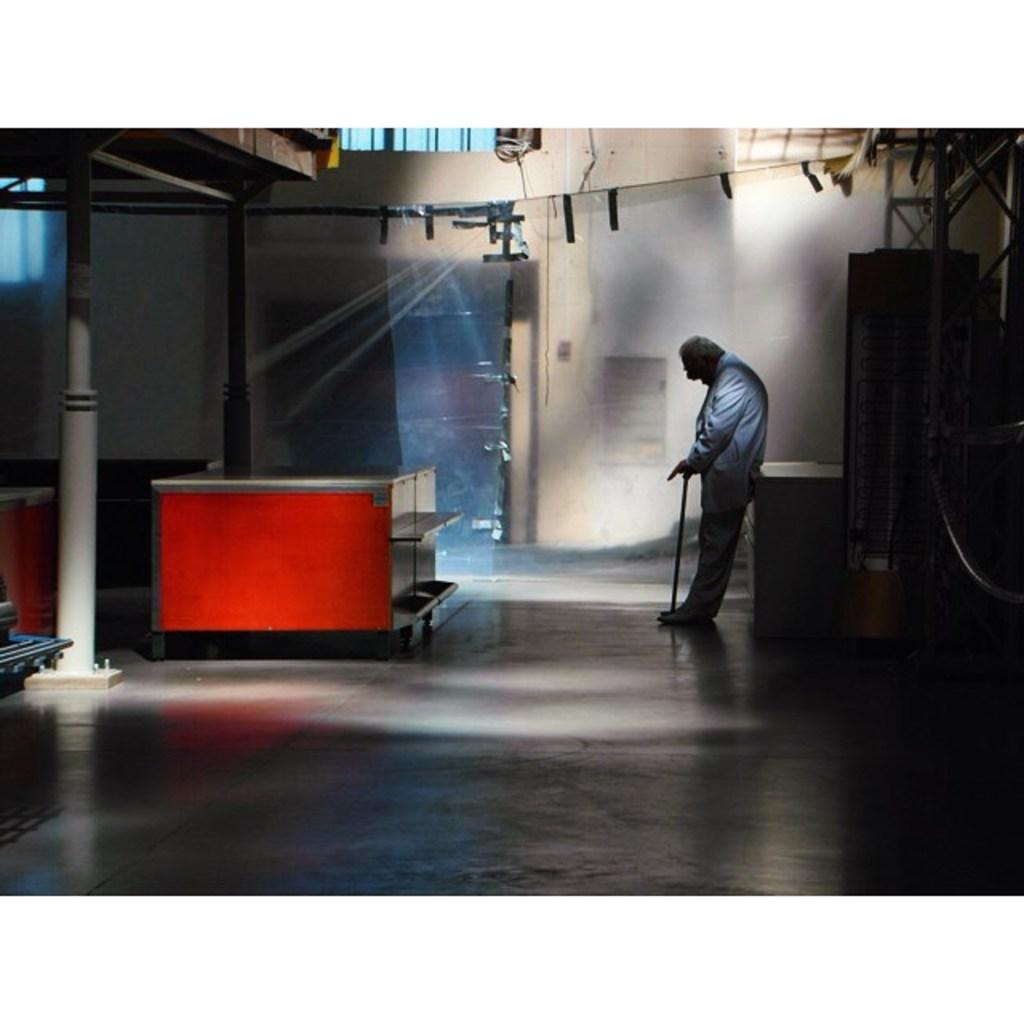What is the man in the image doing? The man is standing in the image and holding a stick. What objects can be seen in the image besides the man? There are tables, poles, a metal frame, and a wall in the image. Can you describe the man's position in relation to the other objects? The man is standing near the tables and poles, and the metal frame and wall are visible in the background. What riddle does the man pose to the viewer in the image? There is no riddle present in the image; the man is simply standing and holding a stick. 